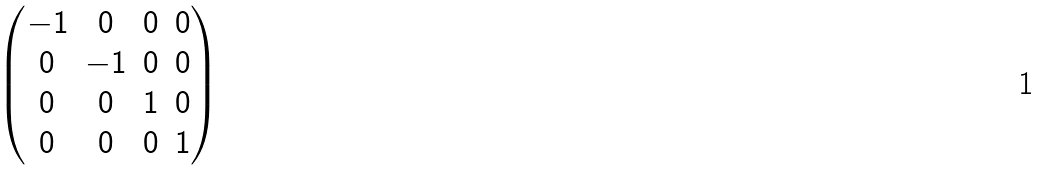Convert formula to latex. <formula><loc_0><loc_0><loc_500><loc_500>\begin{pmatrix} - 1 & 0 & 0 & 0 \\ 0 & - 1 & 0 & 0 \\ 0 & 0 & 1 & 0 \\ 0 & 0 & 0 & 1 \\ \end{pmatrix}</formula> 